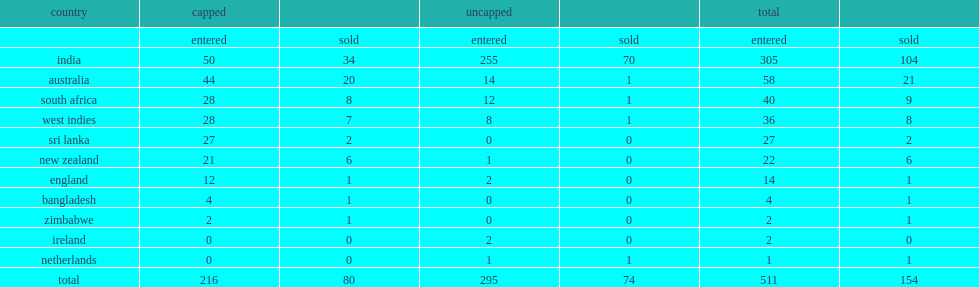How many players were sold? 154.0. 